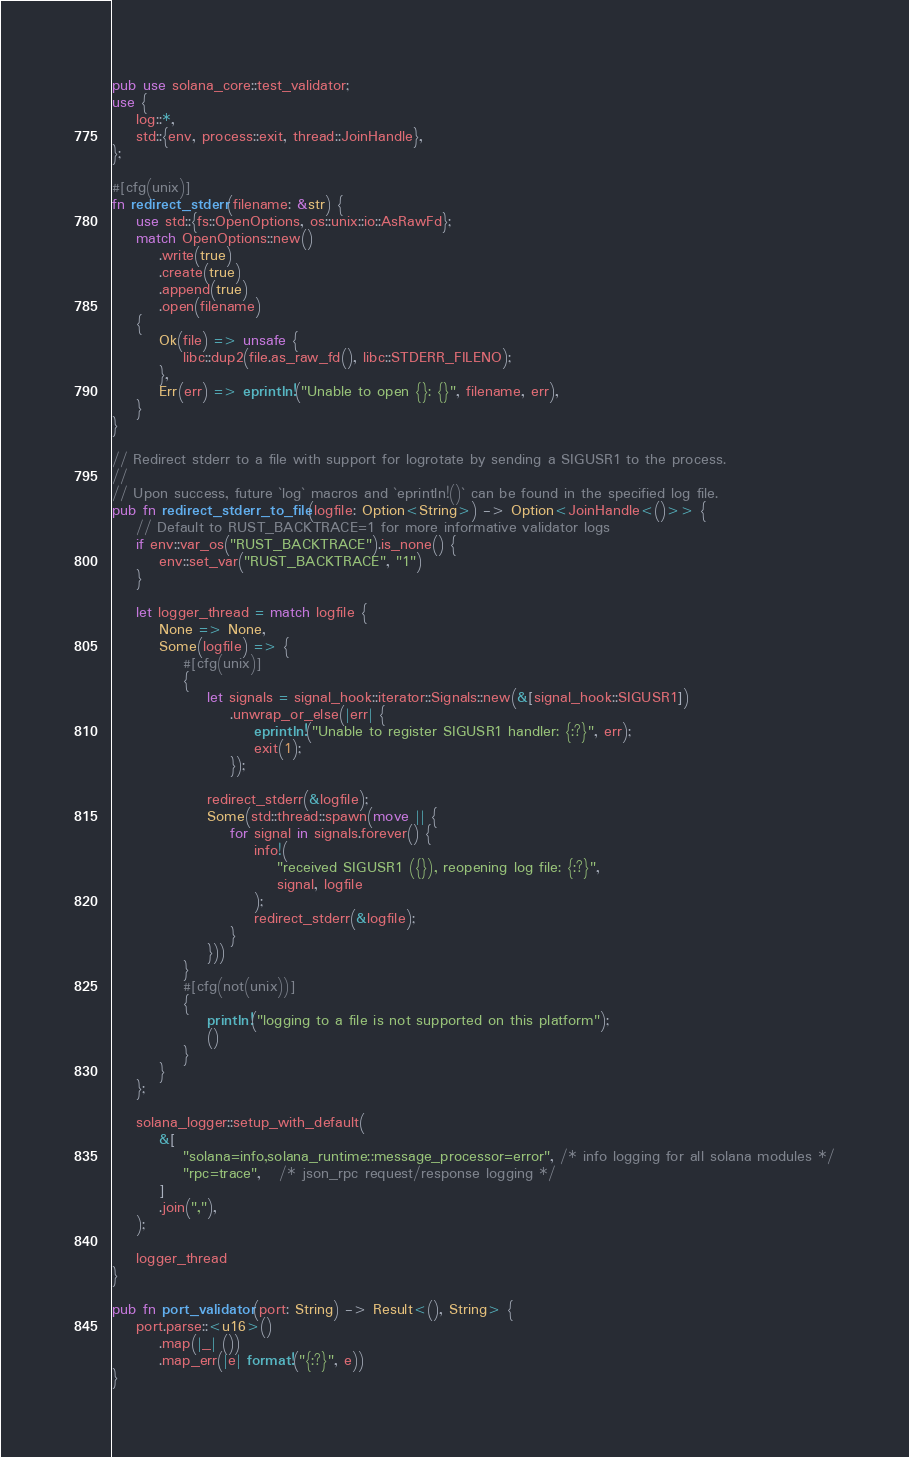<code> <loc_0><loc_0><loc_500><loc_500><_Rust_>pub use solana_core::test_validator;
use {
    log::*,
    std::{env, process::exit, thread::JoinHandle},
};

#[cfg(unix)]
fn redirect_stderr(filename: &str) {
    use std::{fs::OpenOptions, os::unix::io::AsRawFd};
    match OpenOptions::new()
        .write(true)
        .create(true)
        .append(true)
        .open(filename)
    {
        Ok(file) => unsafe {
            libc::dup2(file.as_raw_fd(), libc::STDERR_FILENO);
        },
        Err(err) => eprintln!("Unable to open {}: {}", filename, err),
    }
}

// Redirect stderr to a file with support for logrotate by sending a SIGUSR1 to the process.
//
// Upon success, future `log` macros and `eprintln!()` can be found in the specified log file.
pub fn redirect_stderr_to_file(logfile: Option<String>) -> Option<JoinHandle<()>> {
    // Default to RUST_BACKTRACE=1 for more informative validator logs
    if env::var_os("RUST_BACKTRACE").is_none() {
        env::set_var("RUST_BACKTRACE", "1")
    }

    let logger_thread = match logfile {
        None => None,
        Some(logfile) => {
            #[cfg(unix)]
            {
                let signals = signal_hook::iterator::Signals::new(&[signal_hook::SIGUSR1])
                    .unwrap_or_else(|err| {
                        eprintln!("Unable to register SIGUSR1 handler: {:?}", err);
                        exit(1);
                    });

                redirect_stderr(&logfile);
                Some(std::thread::spawn(move || {
                    for signal in signals.forever() {
                        info!(
                            "received SIGUSR1 ({}), reopening log file: {:?}",
                            signal, logfile
                        );
                        redirect_stderr(&logfile);
                    }
                }))
            }
            #[cfg(not(unix))]
            {
                println!("logging to a file is not supported on this platform");
                ()
            }
        }
    };

    solana_logger::setup_with_default(
        &[
            "solana=info,solana_runtime::message_processor=error", /* info logging for all solana modules */
            "rpc=trace",   /* json_rpc request/response logging */
        ]
        .join(","),
    );

    logger_thread
}

pub fn port_validator(port: String) -> Result<(), String> {
    port.parse::<u16>()
        .map(|_| ())
        .map_err(|e| format!("{:?}", e))
}
</code> 